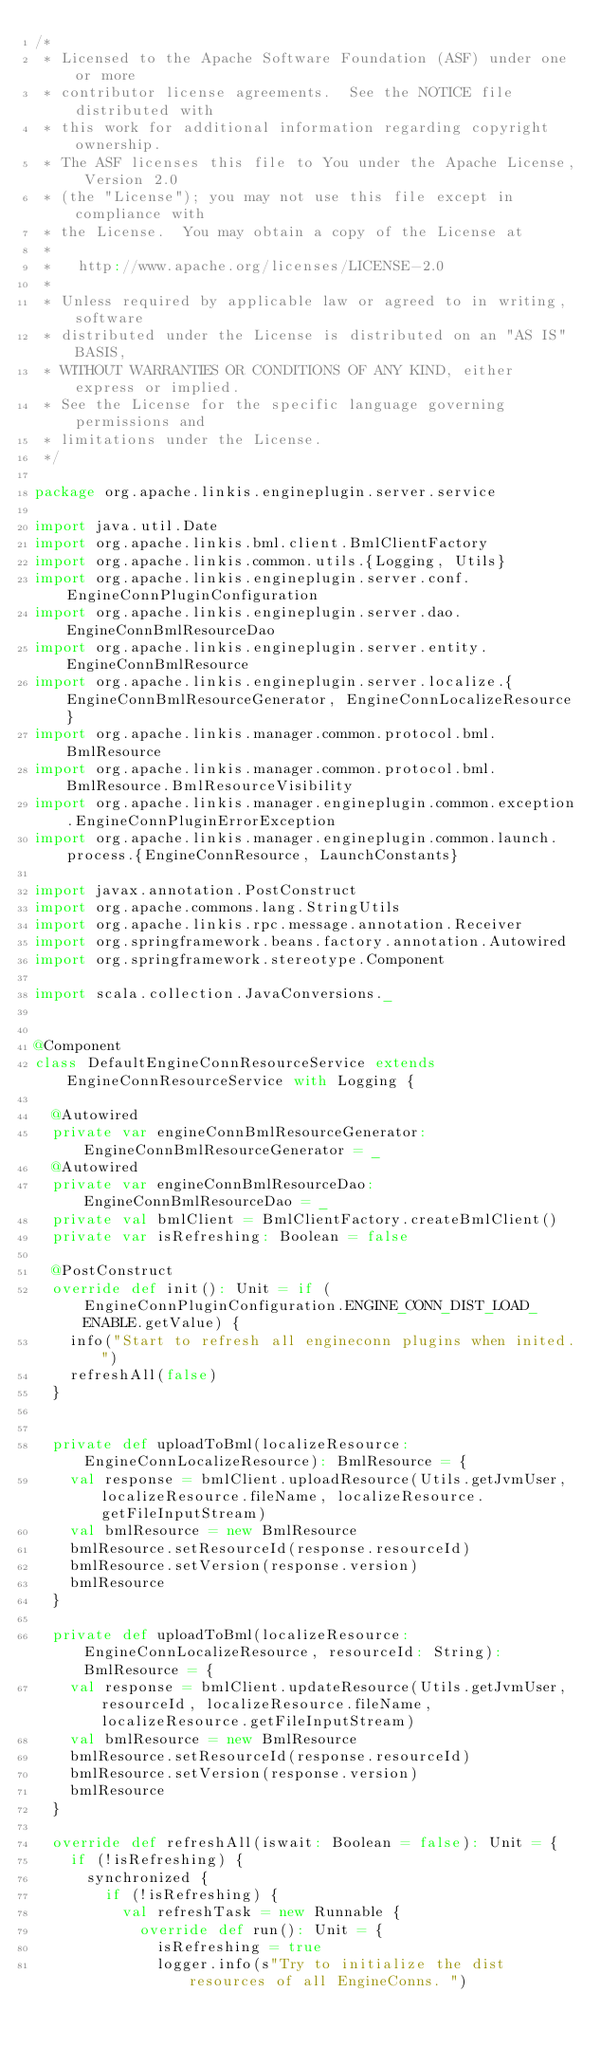Convert code to text. <code><loc_0><loc_0><loc_500><loc_500><_Scala_>/*
 * Licensed to the Apache Software Foundation (ASF) under one or more
 * contributor license agreements.  See the NOTICE file distributed with
 * this work for additional information regarding copyright ownership.
 * The ASF licenses this file to You under the Apache License, Version 2.0
 * (the "License"); you may not use this file except in compliance with
 * the License.  You may obtain a copy of the License at
 * 
 *   http://www.apache.org/licenses/LICENSE-2.0
 * 
 * Unless required by applicable law or agreed to in writing, software
 * distributed under the License is distributed on an "AS IS" BASIS,
 * WITHOUT WARRANTIES OR CONDITIONS OF ANY KIND, either express or implied.
 * See the License for the specific language governing permissions and
 * limitations under the License.
 */
 
package org.apache.linkis.engineplugin.server.service

import java.util.Date
import org.apache.linkis.bml.client.BmlClientFactory
import org.apache.linkis.common.utils.{Logging, Utils}
import org.apache.linkis.engineplugin.server.conf.EngineConnPluginConfiguration
import org.apache.linkis.engineplugin.server.dao.EngineConnBmlResourceDao
import org.apache.linkis.engineplugin.server.entity.EngineConnBmlResource
import org.apache.linkis.engineplugin.server.localize.{EngineConnBmlResourceGenerator, EngineConnLocalizeResource}
import org.apache.linkis.manager.common.protocol.bml.BmlResource
import org.apache.linkis.manager.common.protocol.bml.BmlResource.BmlResourceVisibility
import org.apache.linkis.manager.engineplugin.common.exception.EngineConnPluginErrorException
import org.apache.linkis.manager.engineplugin.common.launch.process.{EngineConnResource, LaunchConstants}

import javax.annotation.PostConstruct
import org.apache.commons.lang.StringUtils
import org.apache.linkis.rpc.message.annotation.Receiver
import org.springframework.beans.factory.annotation.Autowired
import org.springframework.stereotype.Component

import scala.collection.JavaConversions._


@Component
class DefaultEngineConnResourceService extends EngineConnResourceService with Logging {

  @Autowired
  private var engineConnBmlResourceGenerator: EngineConnBmlResourceGenerator = _
  @Autowired
  private var engineConnBmlResourceDao: EngineConnBmlResourceDao = _
  private val bmlClient = BmlClientFactory.createBmlClient()
  private var isRefreshing: Boolean = false

  @PostConstruct
  override def init(): Unit = if (EngineConnPluginConfiguration.ENGINE_CONN_DIST_LOAD_ENABLE.getValue) {
    info("Start to refresh all engineconn plugins when inited.")
    refreshAll(false)
  }


  private def uploadToBml(localizeResource: EngineConnLocalizeResource): BmlResource = {
    val response = bmlClient.uploadResource(Utils.getJvmUser, localizeResource.fileName, localizeResource.getFileInputStream)
    val bmlResource = new BmlResource
    bmlResource.setResourceId(response.resourceId)
    bmlResource.setVersion(response.version)
    bmlResource
  }

  private def uploadToBml(localizeResource: EngineConnLocalizeResource, resourceId: String): BmlResource = {
    val response = bmlClient.updateResource(Utils.getJvmUser, resourceId, localizeResource.fileName, localizeResource.getFileInputStream)
    val bmlResource = new BmlResource
    bmlResource.setResourceId(response.resourceId)
    bmlResource.setVersion(response.version)
    bmlResource
  }

  override def refreshAll(iswait: Boolean = false): Unit = {
    if (!isRefreshing) {
      synchronized {
        if (!isRefreshing) {
          val refreshTask = new Runnable {
            override def run(): Unit = {
              isRefreshing = true
              logger.info(s"Try to initialize the dist resources of all EngineConns. ")</code> 